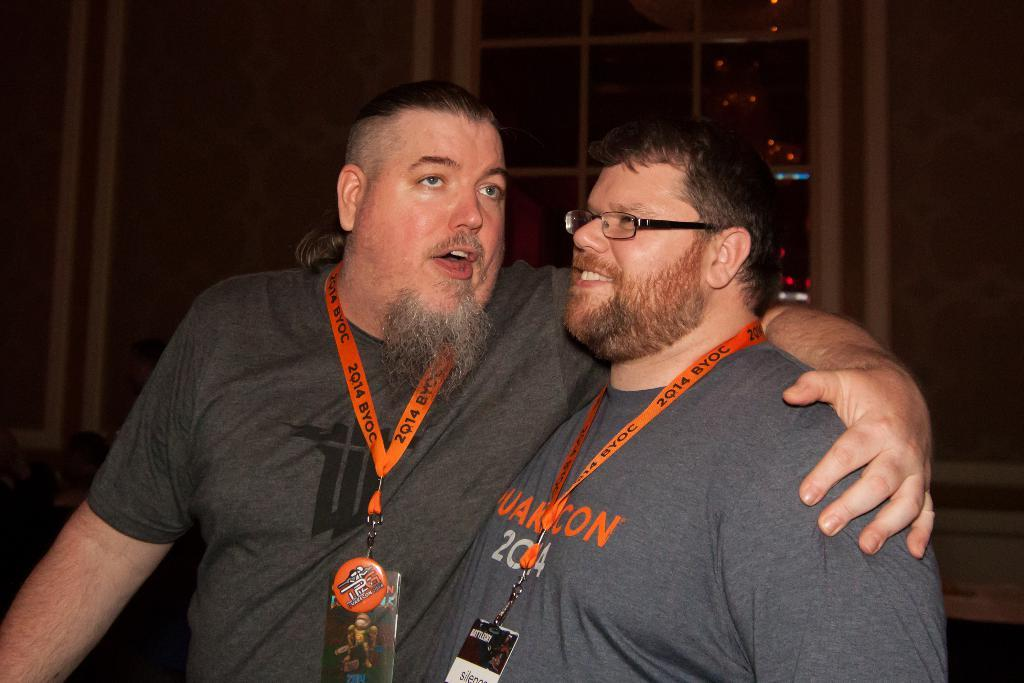How many people are in the image? There are two persons in the image. What is the person on the right wearing? The person on the right is wearing a gray shirt. What can be seen in the background of the image? There is a window visible in the background. What is illuminating the scene in the image? There are lights visible in the image. What type of cloud can be seen in the image? There is no cloud visible in the image. What kind of music is being played in the background of the image? There is no music present in the image. 